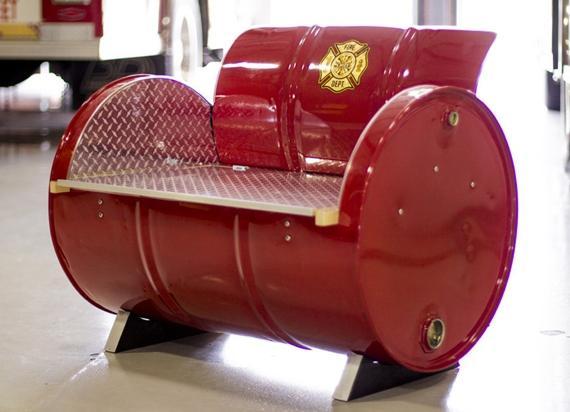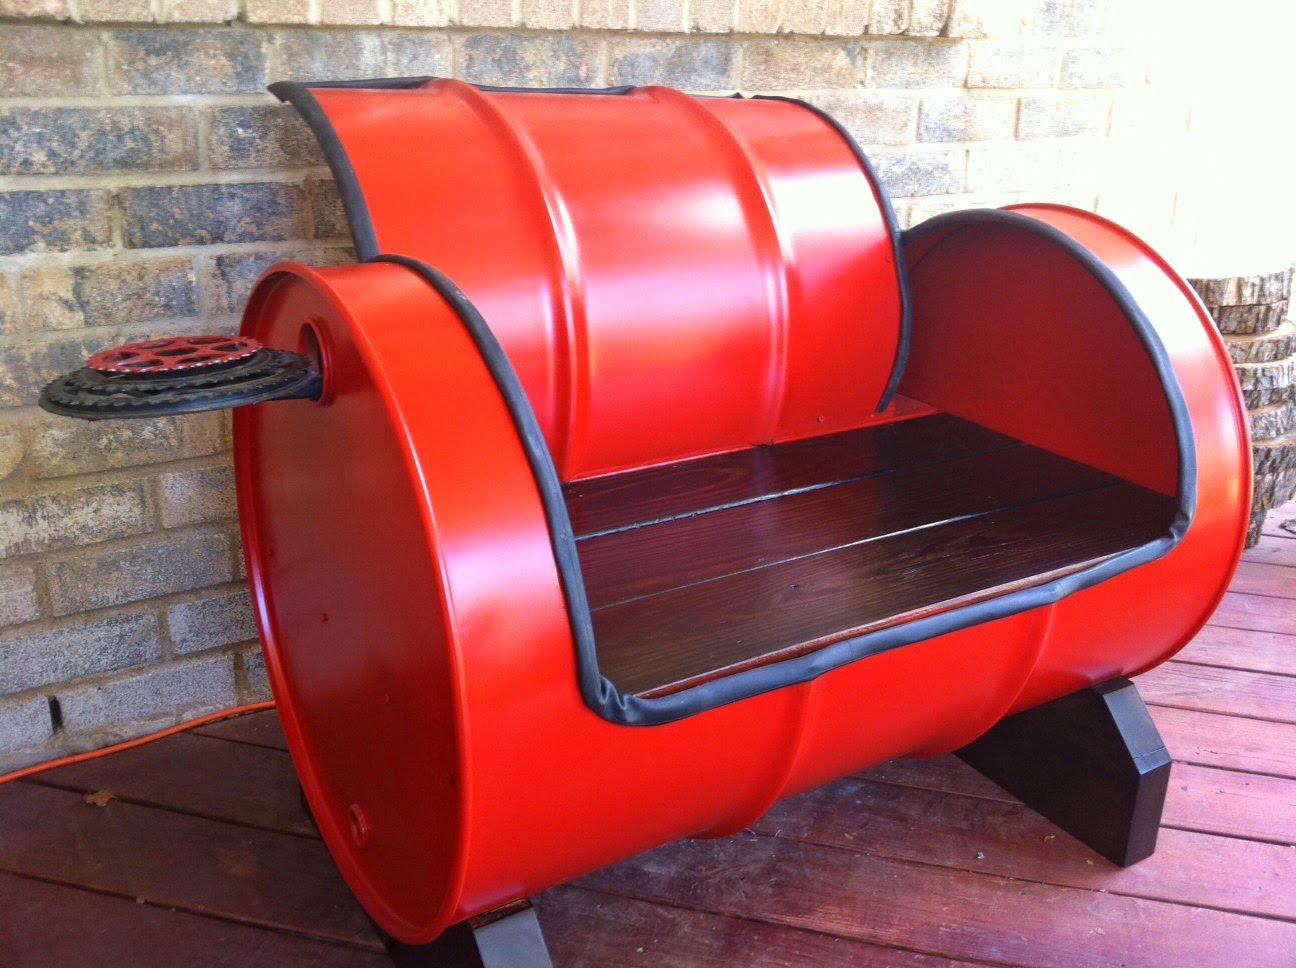The first image is the image on the left, the second image is the image on the right. Examine the images to the left and right. Is the description "The combined images contain two red barrels that have been turned into seats, with the barrel on stands on its side." accurate? Answer yes or no. Yes. The first image is the image on the left, the second image is the image on the right. For the images shown, is this caption "There are at least three chairs that are cushioned." true? Answer yes or no. No. 